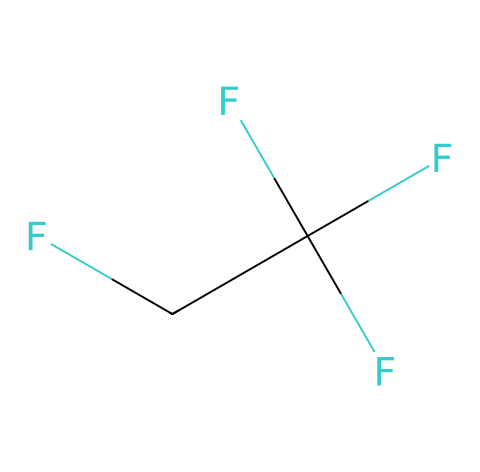What is the name of this refrigerant? The SMILES representation indicates a refrigerant molecule composed of specific atoms. R-134a is a common name for this refrigerant, which is recognized by its specific arrangement of fluorine, carbon, and chlorine atoms in the structure.
Answer: R-134a How many carbon atoms are in R-134a? By analyzing the SMILES, we see the notation 'CF' appears multiple times, suggesting there are carbon atoms present. Counting from the structure reveals there are two carbon atoms in total.
Answer: 2 How many fluorine atoms are in R-134a? In the structure, we can observe several 'F's designated in the SMILES. Specifically, R-134a has three fluorine atoms noticeable in its structure.
Answer: 3 What type of chemical compound is R-134a? R-134a is known as a fluorinated hydrocarbon. It is categorized as a refrigerant primarily used in air conditioning systems due to its properties.
Answer: fluorinated hydrocarbon What common property of R-134a allows it to be used in refrigeration? The chemical structure indicates that R-134a has a low boiling point, making it suitable for heat exchange in cooling applications. Its ability to evaporate at low temperatures is critical for its function as a refrigerant.
Answer: low boiling point How does the presence of fluorine affect the environmental impact of R-134a? The fluorine atoms in R-134a contribute to its global warming potential. Being a greenhouse gas, R-134a can trap heat in the atmosphere, even if it doesn’t damage the ozone layer as previous refrigerants did.
Answer: global warming potential What would happen if R-134a were to leak into the atmosphere? If R-134a leaks, due to its properties as a refrigerant, it can contribute to climate change by acting as a greenhouse gas. Its release has implications for environmental regulations as it has a defined global warming potential.
Answer: environmental impact 